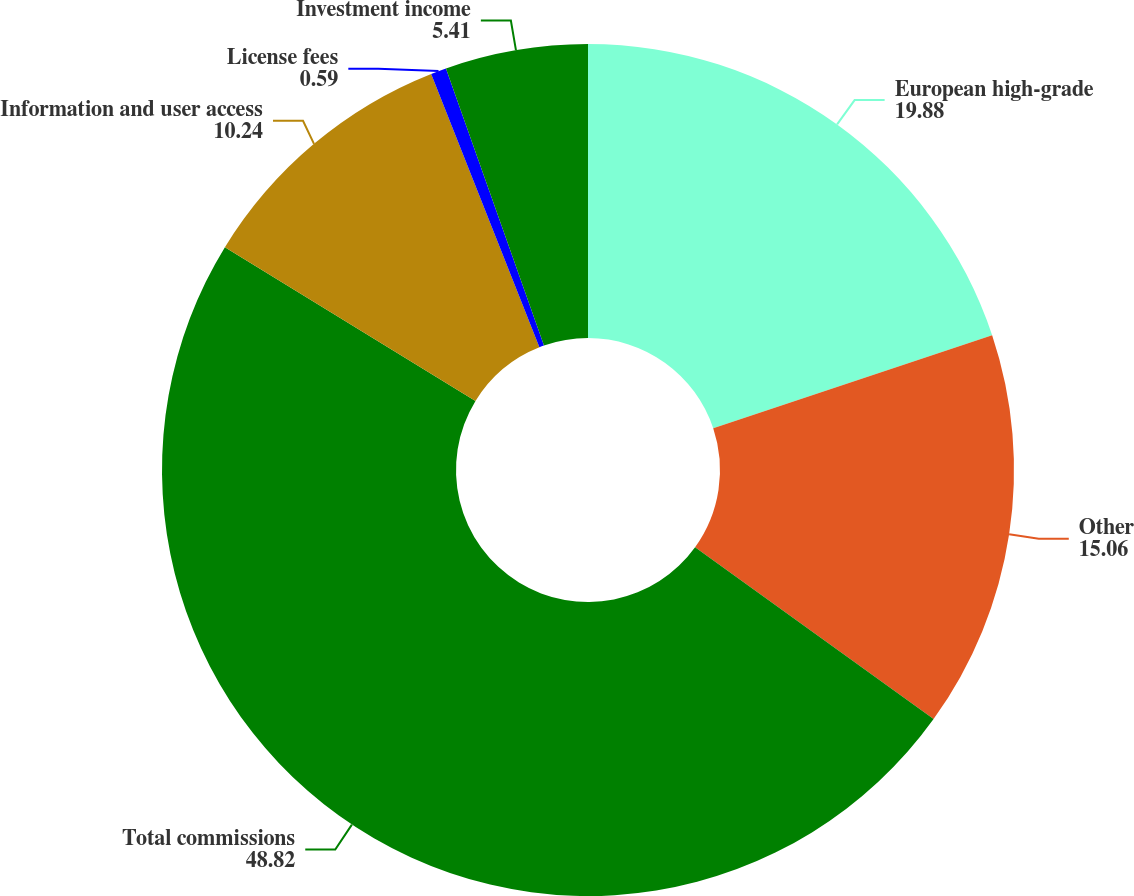<chart> <loc_0><loc_0><loc_500><loc_500><pie_chart><fcel>European high-grade<fcel>Other<fcel>Total commissions<fcel>Information and user access<fcel>License fees<fcel>Investment income<nl><fcel>19.88%<fcel>15.06%<fcel>48.82%<fcel>10.24%<fcel>0.59%<fcel>5.41%<nl></chart> 